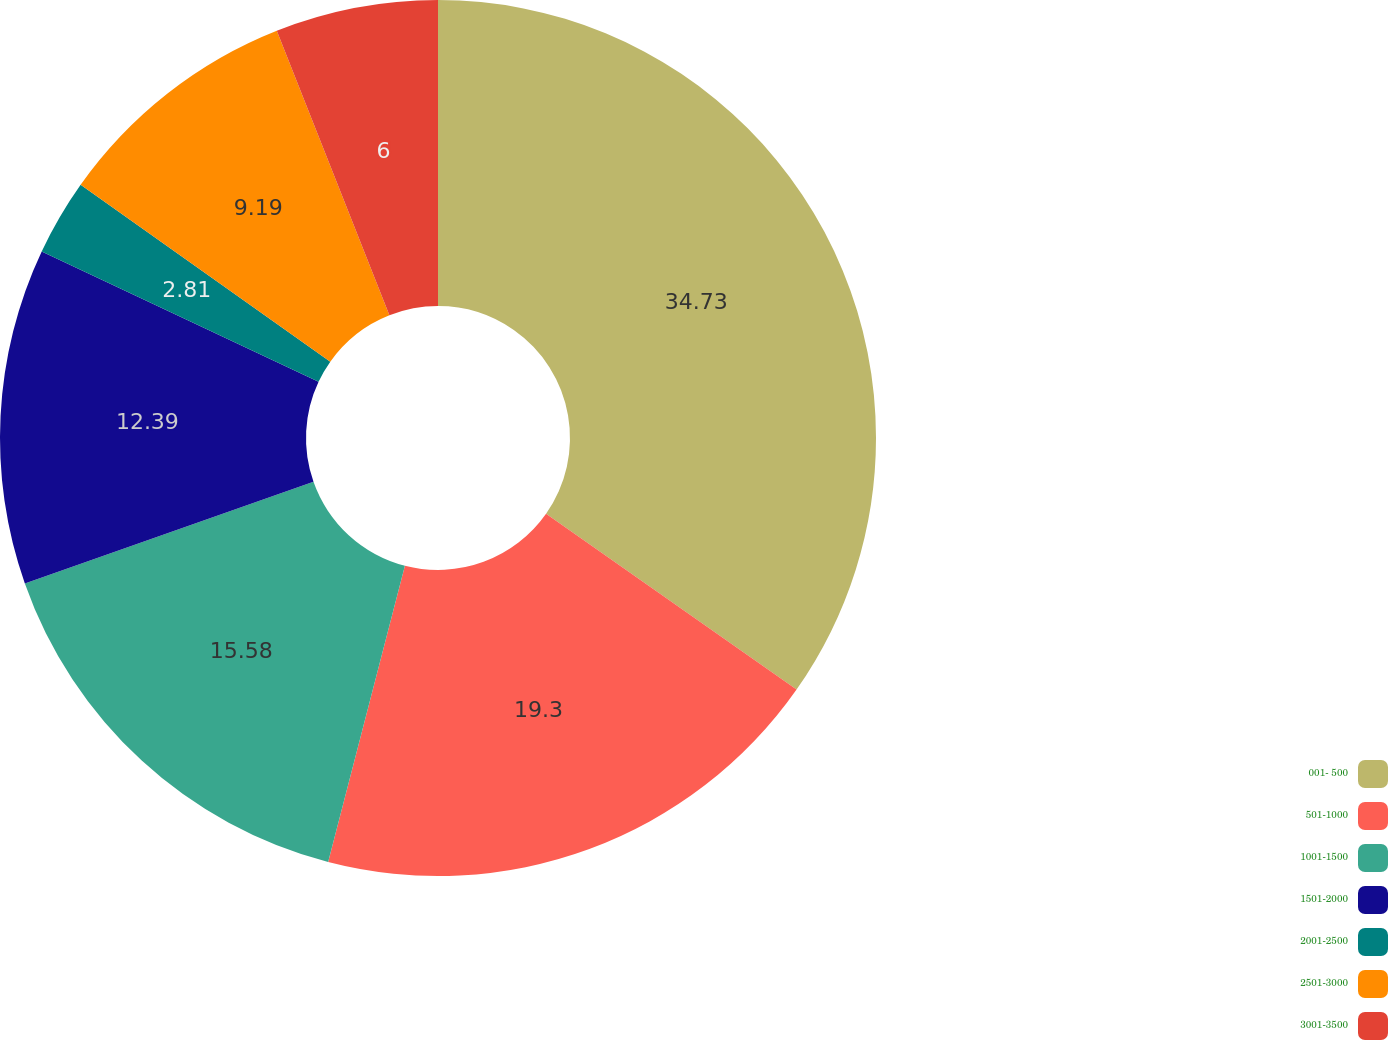<chart> <loc_0><loc_0><loc_500><loc_500><pie_chart><fcel>001- 500<fcel>501-1000<fcel>1001-1500<fcel>1501-2000<fcel>2001-2500<fcel>2501-3000<fcel>3001-3500<nl><fcel>34.74%<fcel>19.3%<fcel>15.58%<fcel>12.39%<fcel>2.81%<fcel>9.19%<fcel>6.0%<nl></chart> 